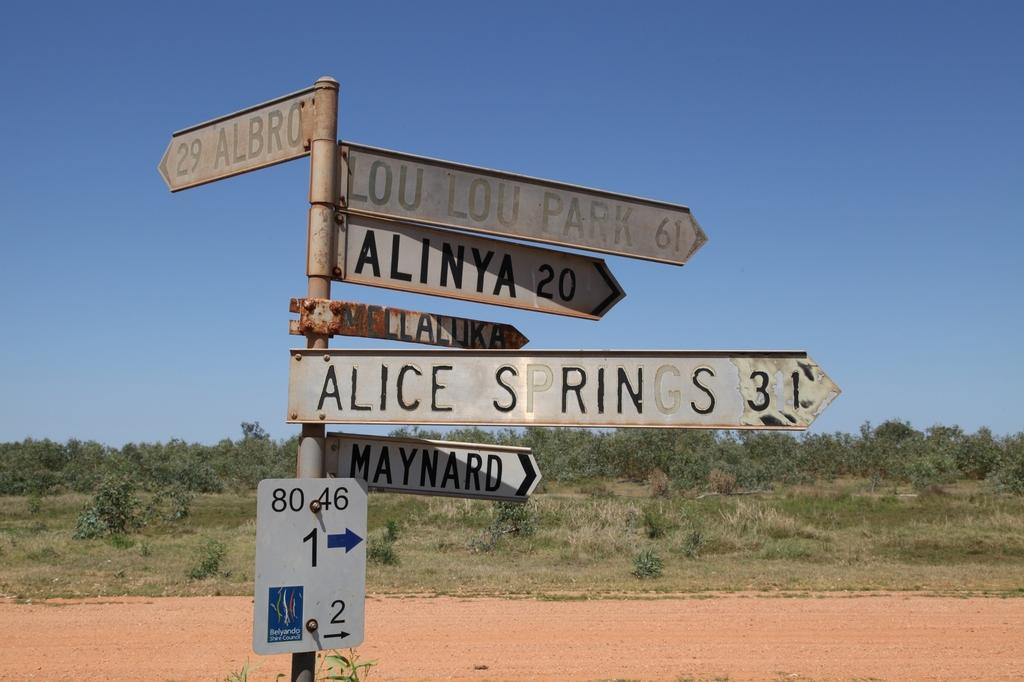Provide a one-sentence caption for the provided image. A sign showing the distance to Alice Springs and Maynard stands in the desert. 